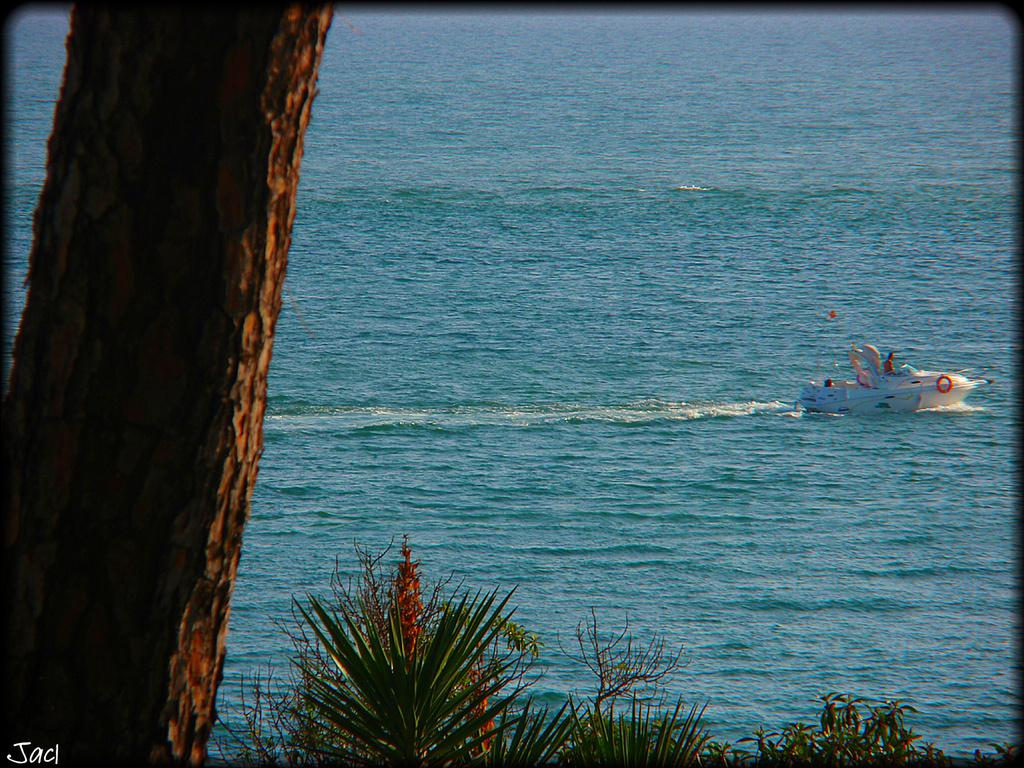What is in the water in the image? There is a boat in the water in the image. Who or what is inside the boat? People are sitting in the boat. What can be seen near the water in the image? There is a tree trunk visible, and leaves are present in the image. What type of large body of water is visible in the image? The sea is visible in the image. Is there any additional information about the image itself? There is a watermark on the bottom left of the image. What type of berry is being eaten by the rabbits in the image? There are no rabbits or berries present in the image. What sound do the people in the boat make in the image? The image does not depict any sounds or actions, so we cannot determine what sound the people make. 